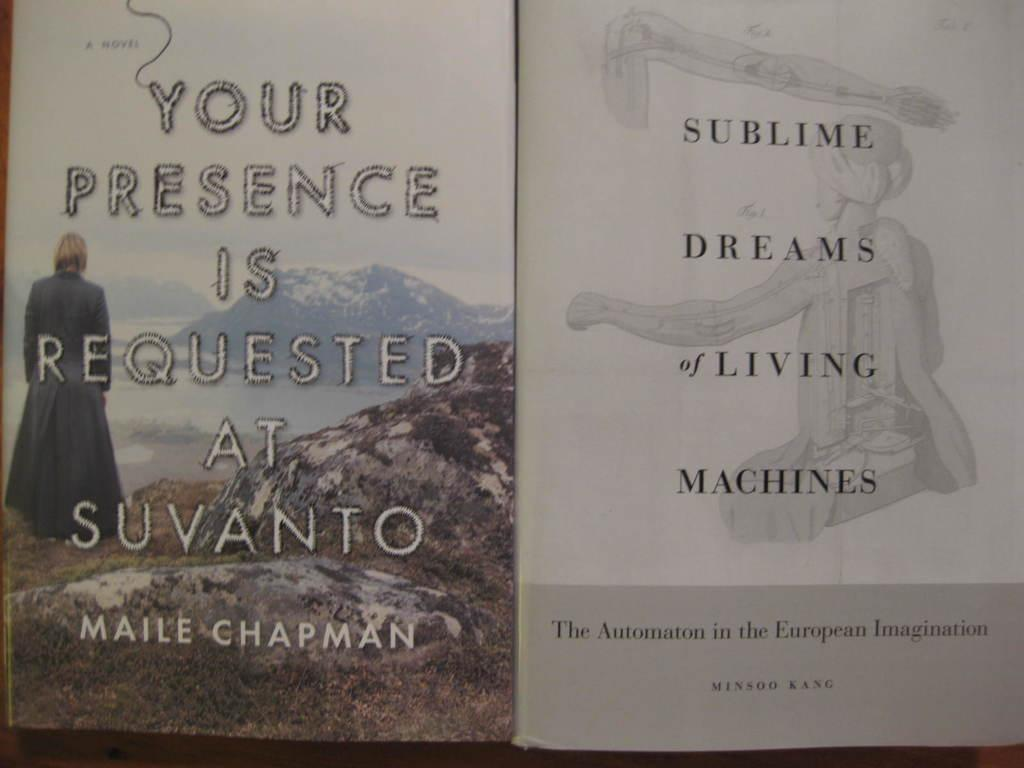Provide a one-sentence caption for the provided image. The book "Your Presence is Requested at Suvanto" next to the book "Sublime Dreams of Living Machines". 